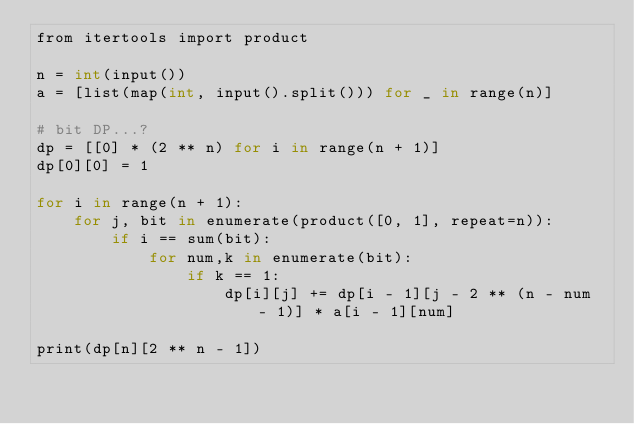<code> <loc_0><loc_0><loc_500><loc_500><_Cython_>from itertools import product

n = int(input())
a = [list(map(int, input().split())) for _ in range(n)]

# bit DP...?
dp = [[0] * (2 ** n) for i in range(n + 1)]
dp[0][0] = 1

for i in range(n + 1):
    for j, bit in enumerate(product([0, 1], repeat=n)):
        if i == sum(bit):
            for num,k in enumerate(bit):
                if k == 1:
                    dp[i][j] += dp[i - 1][j - 2 ** (n - num - 1)] * a[i - 1][num]

print(dp[n][2 ** n - 1])

</code> 